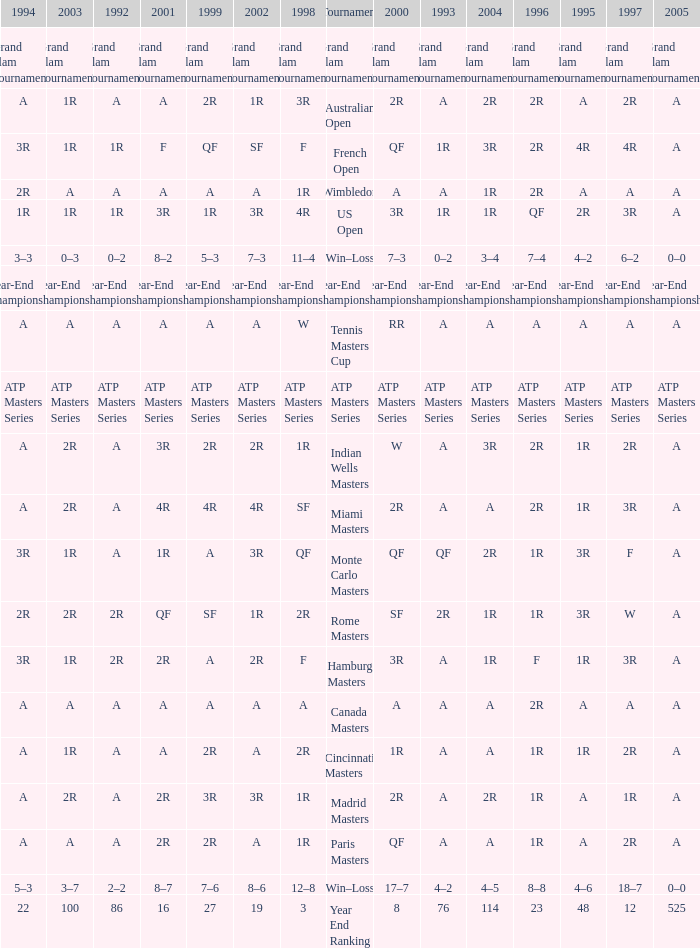Parse the full table. {'header': ['1994', '2003', '1992', '2001', '1999', '2002', '1998', 'Tournament', '2000', '1993', '2004', '1996', '1995', '1997', '2005'], 'rows': [['Grand Slam Tournaments', 'Grand Slam Tournaments', 'Grand Slam Tournaments', 'Grand Slam Tournaments', 'Grand Slam Tournaments', 'Grand Slam Tournaments', 'Grand Slam Tournaments', 'Grand Slam Tournaments', 'Grand Slam Tournaments', 'Grand Slam Tournaments', 'Grand Slam Tournaments', 'Grand Slam Tournaments', 'Grand Slam Tournaments', 'Grand Slam Tournaments', 'Grand Slam Tournaments'], ['A', '1R', 'A', 'A', '2R', '1R', '3R', 'Australian Open', '2R', 'A', '2R', '2R', 'A', '2R', 'A'], ['3R', '1R', '1R', 'F', 'QF', 'SF', 'F', 'French Open', 'QF', '1R', '3R', '2R', '4R', '4R', 'A'], ['2R', 'A', 'A', 'A', 'A', 'A', '1R', 'Wimbledon', 'A', 'A', '1R', '2R', 'A', 'A', 'A'], ['1R', '1R', '1R', '3R', '1R', '3R', '4R', 'US Open', '3R', '1R', '1R', 'QF', '2R', '3R', 'A'], ['3–3', '0–3', '0–2', '8–2', '5–3', '7–3', '11–4', 'Win–Loss', '7–3', '0–2', '3–4', '7–4', '4–2', '6–2', '0–0'], ['Year-End Championship', 'Year-End Championship', 'Year-End Championship', 'Year-End Championship', 'Year-End Championship', 'Year-End Championship', 'Year-End Championship', 'Year-End Championship', 'Year-End Championship', 'Year-End Championship', 'Year-End Championship', 'Year-End Championship', 'Year-End Championship', 'Year-End Championship', 'Year-End Championship'], ['A', 'A', 'A', 'A', 'A', 'A', 'W', 'Tennis Masters Cup', 'RR', 'A', 'A', 'A', 'A', 'A', 'A'], ['ATP Masters Series', 'ATP Masters Series', 'ATP Masters Series', 'ATP Masters Series', 'ATP Masters Series', 'ATP Masters Series', 'ATP Masters Series', 'ATP Masters Series', 'ATP Masters Series', 'ATP Masters Series', 'ATP Masters Series', 'ATP Masters Series', 'ATP Masters Series', 'ATP Masters Series', 'ATP Masters Series'], ['A', '2R', 'A', '3R', '2R', '2R', '1R', 'Indian Wells Masters', 'W', 'A', '3R', '2R', '1R', '2R', 'A'], ['A', '2R', 'A', '4R', '4R', '4R', 'SF', 'Miami Masters', '2R', 'A', 'A', '2R', '1R', '3R', 'A'], ['3R', '1R', 'A', '1R', 'A', '3R', 'QF', 'Monte Carlo Masters', 'QF', 'QF', '2R', '1R', '3R', 'F', 'A'], ['2R', '2R', '2R', 'QF', 'SF', '1R', '2R', 'Rome Masters', 'SF', '2R', '1R', '1R', '3R', 'W', 'A'], ['3R', '1R', '2R', '2R', 'A', '2R', 'F', 'Hamburg Masters', '3R', 'A', '1R', 'F', '1R', '3R', 'A'], ['A', 'A', 'A', 'A', 'A', 'A', 'A', 'Canada Masters', 'A', 'A', 'A', '2R', 'A', 'A', 'A'], ['A', '1R', 'A', 'A', '2R', 'A', '2R', 'Cincinnati Masters', '1R', 'A', 'A', '1R', '1R', '2R', 'A'], ['A', '2R', 'A', '2R', '3R', '3R', '1R', 'Madrid Masters', '2R', 'A', '2R', '1R', 'A', '1R', 'A'], ['A', 'A', 'A', '2R', '2R', 'A', '1R', 'Paris Masters', 'QF', 'A', 'A', '1R', 'A', '2R', 'A'], ['5–3', '3–7', '2–2', '8–7', '7–6', '8–6', '12–8', 'Win–Loss', '17–7', '4–2', '4–5', '8–8', '4–6', '18–7', '0–0'], ['22', '100', '86', '16', '27', '19', '3', 'Year End Ranking', '8', '76', '114', '23', '48', '12', '525']]} What is Tournament, when 2000 is "A"? Wimbledon, Canada Masters. 